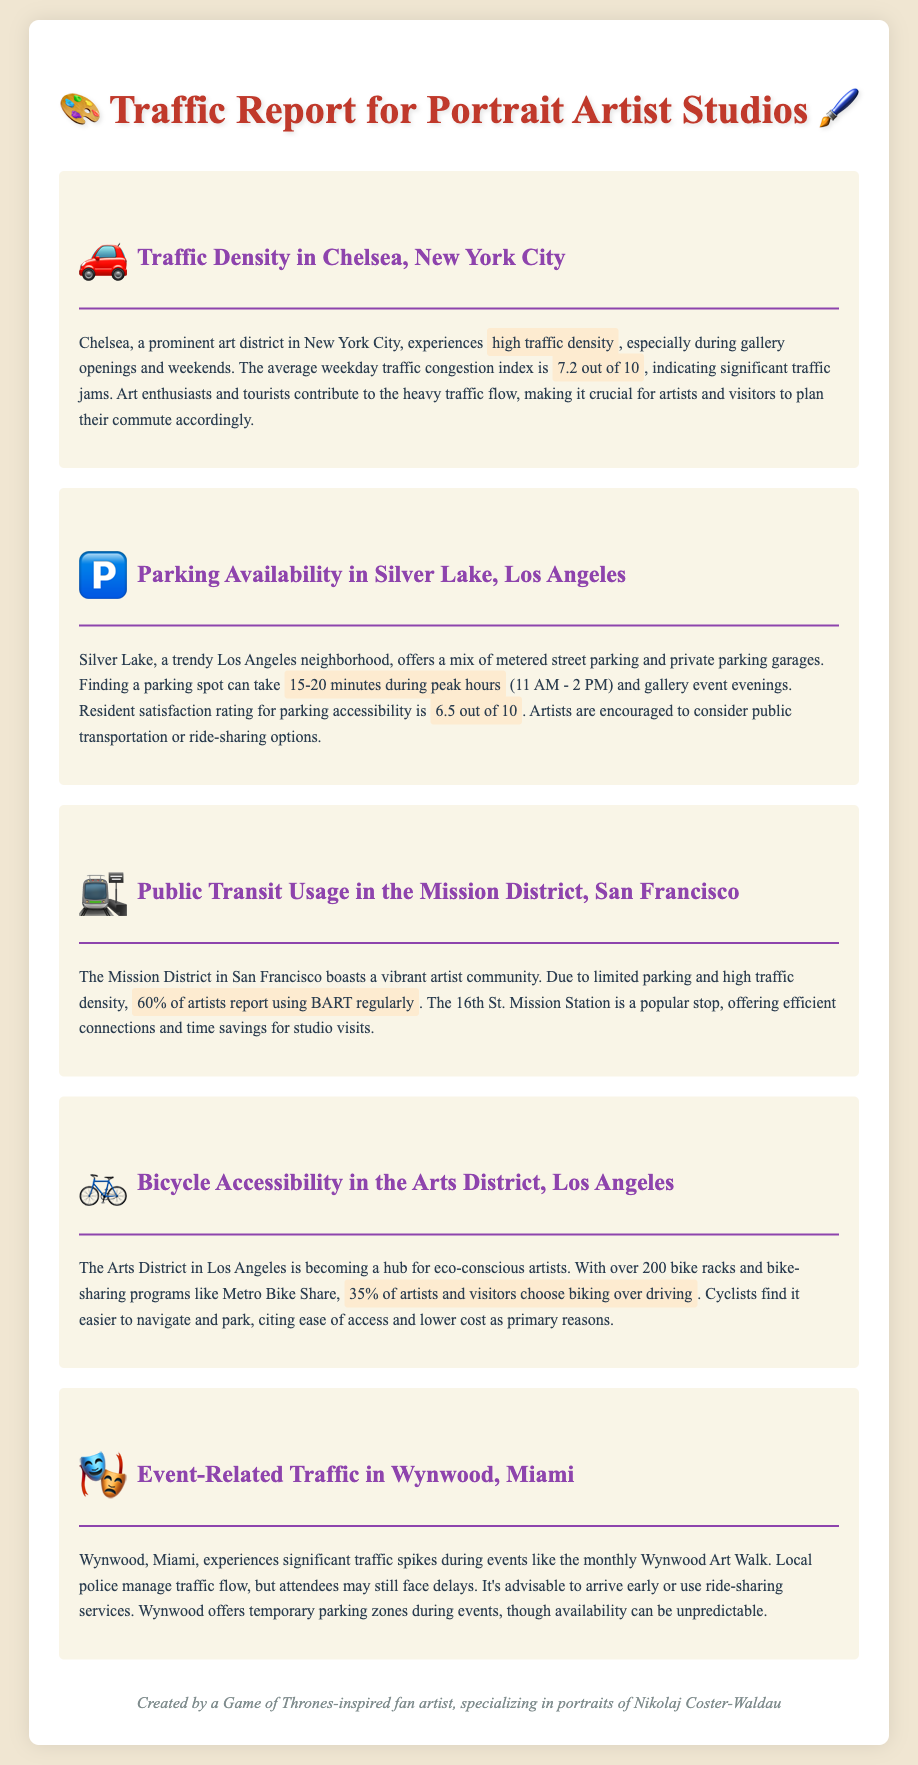what is the average traffic congestion index in Chelsea? The average weekday traffic congestion index in Chelsea is 7.2 out of 10.
Answer: 7.2 out of 10 how long does it take to find a parking spot in Silver Lake during peak hours? Finding a parking spot in Silver Lake can take 15-20 minutes during peak hours.
Answer: 15-20 minutes what percentage of artists in the Mission District use BART regularly? 60% of artists in the Mission District report using BART regularly.
Answer: 60% how many bike racks are there in the Arts District? The Arts District has over 200 bike racks available.
Answer: over 200 what is the resident satisfaction rating for parking accessibility in Silver Lake? The resident satisfaction rating for parking accessibility in Silver Lake is 6.5 out of 10.
Answer: 6.5 out of 10 what alternative transportation methods are suggested for artists in Silver Lake? Artists are encouraged to consider public transportation or ride-sharing options.
Answer: public transportation or ride-sharing what traffic flow management is used during events in Wynwood? Local police manage traffic flow during events in Wynwood.
Answer: local police what is the main reason cyclists prefer biking over driving in the Arts District? Cyclists find it easier to navigate and park, citing ease of access and lower cost as primary reasons.
Answer: ease of access and lower cost 